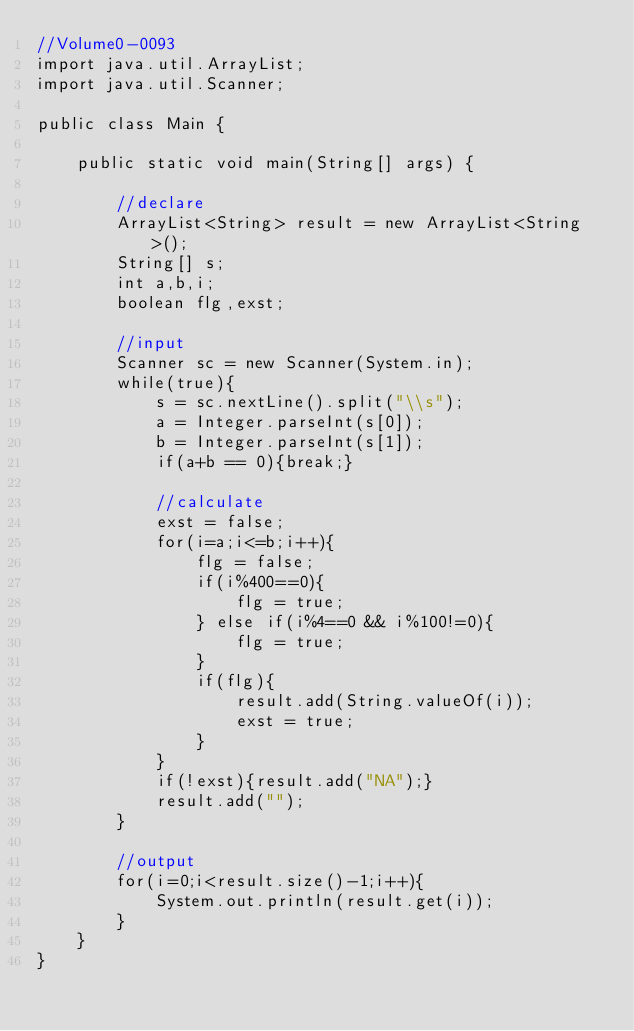<code> <loc_0><loc_0><loc_500><loc_500><_Java_>//Volume0-0093
import java.util.ArrayList;
import java.util.Scanner;

public class Main {

	public static void main(String[] args) {

		//declare
		ArrayList<String> result = new ArrayList<String>();
		String[] s;
		int a,b,i;
		boolean flg,exst;

        //input
        Scanner sc = new Scanner(System.in);
        while(true){
        	s = sc.nextLine().split("\\s");
        	a = Integer.parseInt(s[0]);
        	b = Integer.parseInt(s[1]);
        	if(a+b == 0){break;}

        	//calculate
        	exst = false;
        	for(i=a;i<=b;i++){
        		flg = false;
        		if(i%400==0){
        			flg = true;
       			} else if(i%4==0 && i%100!=0){
					flg = true;
				}
        		if(flg){
        			result.add(String.valueOf(i));
        			exst = true;
       			}
        	}
        	if(!exst){result.add("NA");}
        	result.add("");
        }

        //output
        for(i=0;i<result.size()-1;i++){
        	System.out.println(result.get(i));
       	}
	}
}</code> 